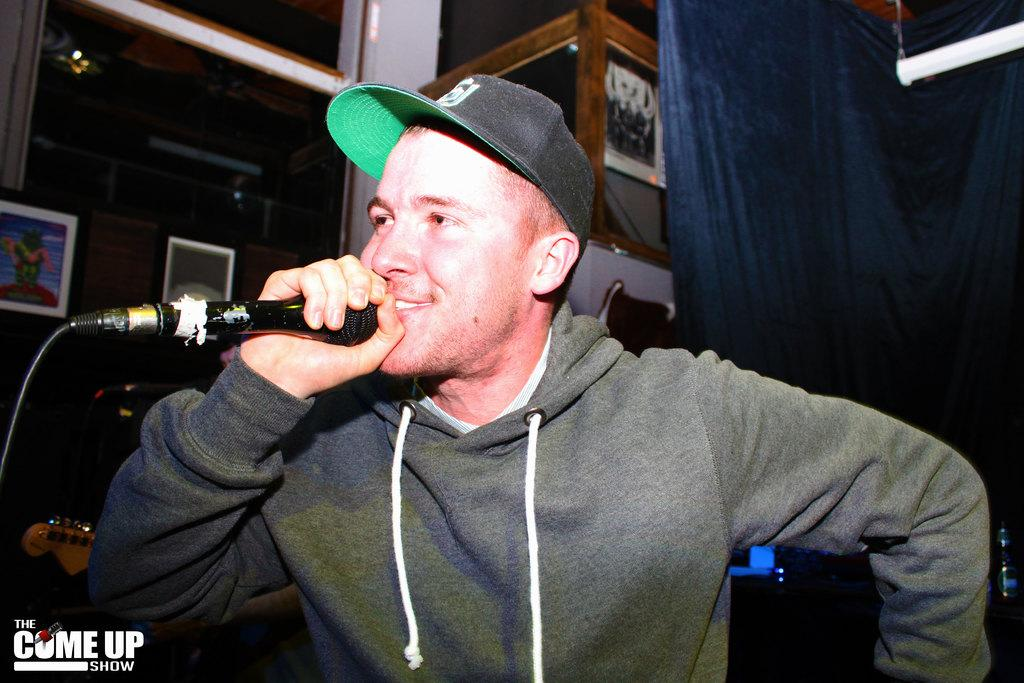Who is present in the image? There is a man in the image. What is the man holding in the image? The man is holding a microphone. What else can be seen in the image besides the man? There are posters in the image. How many snakes are wrapped around the microphone in the image? There are no snakes present in the image. What type of tax is being discussed on the posters in the image? The posters in the image do not mention any taxes. 